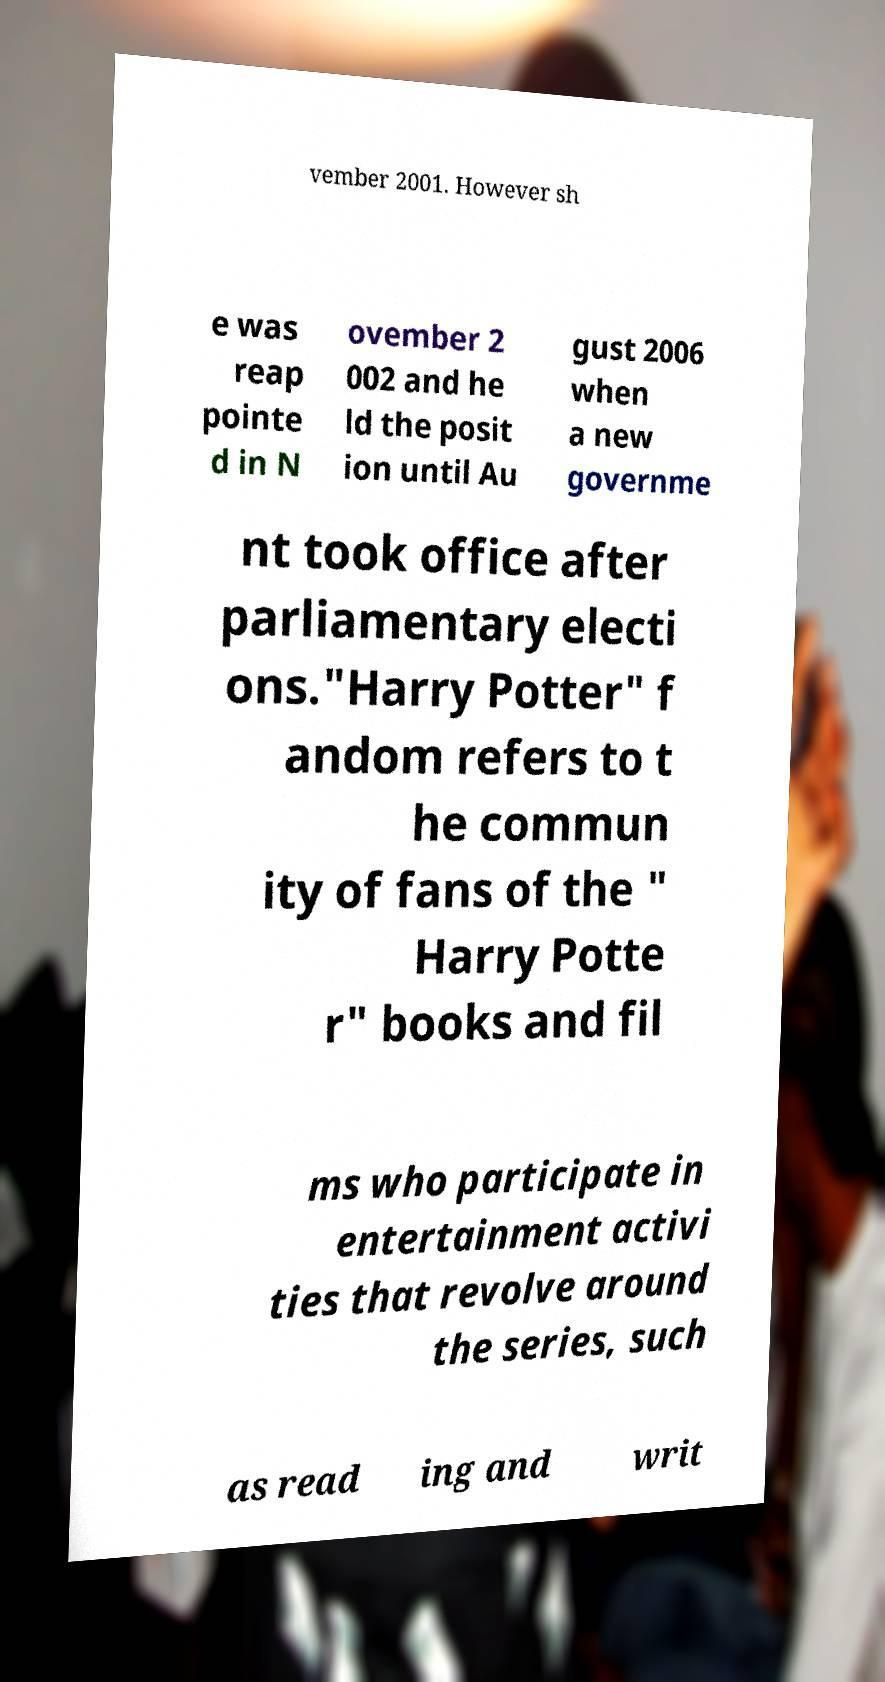Please identify and transcribe the text found in this image. vember 2001. However sh e was reap pointe d in N ovember 2 002 and he ld the posit ion until Au gust 2006 when a new governme nt took office after parliamentary electi ons."Harry Potter" f andom refers to t he commun ity of fans of the " Harry Potte r" books and fil ms who participate in entertainment activi ties that revolve around the series, such as read ing and writ 